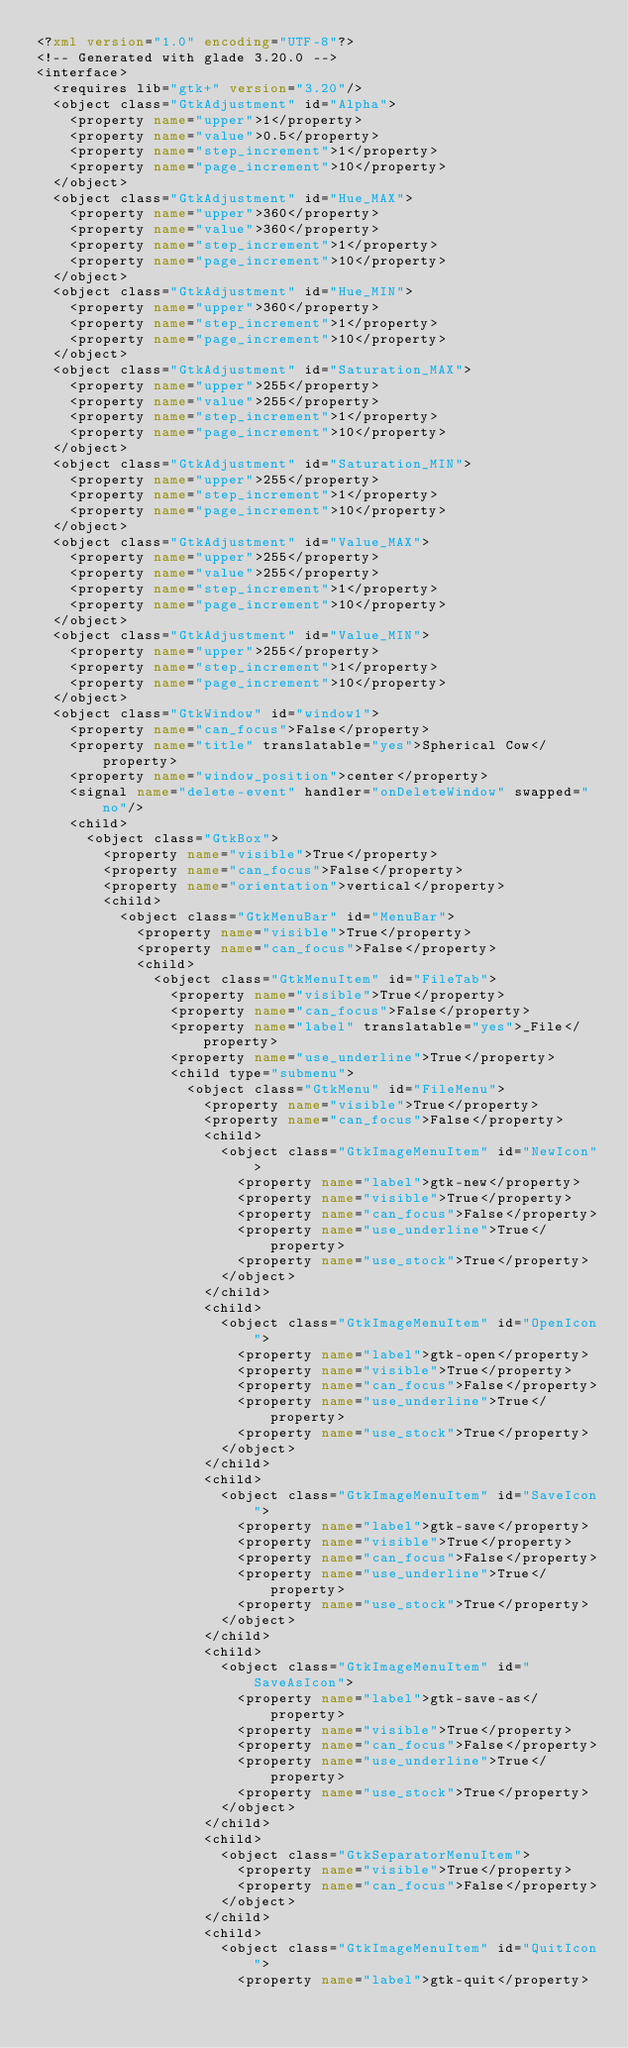<code> <loc_0><loc_0><loc_500><loc_500><_XML_><?xml version="1.0" encoding="UTF-8"?>
<!-- Generated with glade 3.20.0 -->
<interface>
  <requires lib="gtk+" version="3.20"/>
  <object class="GtkAdjustment" id="Alpha">
    <property name="upper">1</property>
    <property name="value">0.5</property>
    <property name="step_increment">1</property>
    <property name="page_increment">10</property>
  </object>
  <object class="GtkAdjustment" id="Hue_MAX">
    <property name="upper">360</property>
    <property name="value">360</property>
    <property name="step_increment">1</property>
    <property name="page_increment">10</property>
  </object>
  <object class="GtkAdjustment" id="Hue_MIN">
    <property name="upper">360</property>
    <property name="step_increment">1</property>
    <property name="page_increment">10</property>
  </object>
  <object class="GtkAdjustment" id="Saturation_MAX">
    <property name="upper">255</property>
    <property name="value">255</property>
    <property name="step_increment">1</property>
    <property name="page_increment">10</property>
  </object>
  <object class="GtkAdjustment" id="Saturation_MIN">
    <property name="upper">255</property>
    <property name="step_increment">1</property>
    <property name="page_increment">10</property>
  </object>
  <object class="GtkAdjustment" id="Value_MAX">
    <property name="upper">255</property>
    <property name="value">255</property>
    <property name="step_increment">1</property>
    <property name="page_increment">10</property>
  </object>
  <object class="GtkAdjustment" id="Value_MIN">
    <property name="upper">255</property>
    <property name="step_increment">1</property>
    <property name="page_increment">10</property>
  </object>
  <object class="GtkWindow" id="window1">
    <property name="can_focus">False</property>
    <property name="title" translatable="yes">Spherical Cow</property>
    <property name="window_position">center</property>
    <signal name="delete-event" handler="onDeleteWindow" swapped="no"/>
    <child>
      <object class="GtkBox">
        <property name="visible">True</property>
        <property name="can_focus">False</property>
        <property name="orientation">vertical</property>
        <child>
          <object class="GtkMenuBar" id="MenuBar">
            <property name="visible">True</property>
            <property name="can_focus">False</property>
            <child>
              <object class="GtkMenuItem" id="FileTab">
                <property name="visible">True</property>
                <property name="can_focus">False</property>
                <property name="label" translatable="yes">_File</property>
                <property name="use_underline">True</property>
                <child type="submenu">
                  <object class="GtkMenu" id="FileMenu">
                    <property name="visible">True</property>
                    <property name="can_focus">False</property>
                    <child>
                      <object class="GtkImageMenuItem" id="NewIcon">
                        <property name="label">gtk-new</property>
                        <property name="visible">True</property>
                        <property name="can_focus">False</property>
                        <property name="use_underline">True</property>
                        <property name="use_stock">True</property>
                      </object>
                    </child>
                    <child>
                      <object class="GtkImageMenuItem" id="OpenIcon">
                        <property name="label">gtk-open</property>
                        <property name="visible">True</property>
                        <property name="can_focus">False</property>
                        <property name="use_underline">True</property>
                        <property name="use_stock">True</property>
                      </object>
                    </child>
                    <child>
                      <object class="GtkImageMenuItem" id="SaveIcon">
                        <property name="label">gtk-save</property>
                        <property name="visible">True</property>
                        <property name="can_focus">False</property>
                        <property name="use_underline">True</property>
                        <property name="use_stock">True</property>
                      </object>
                    </child>
                    <child>
                      <object class="GtkImageMenuItem" id="SaveAsIcon">
                        <property name="label">gtk-save-as</property>
                        <property name="visible">True</property>
                        <property name="can_focus">False</property>
                        <property name="use_underline">True</property>
                        <property name="use_stock">True</property>
                      </object>
                    </child>
                    <child>
                      <object class="GtkSeparatorMenuItem">
                        <property name="visible">True</property>
                        <property name="can_focus">False</property>
                      </object>
                    </child>
                    <child>
                      <object class="GtkImageMenuItem" id="QuitIcon">
                        <property name="label">gtk-quit</property></code> 